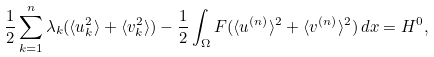<formula> <loc_0><loc_0><loc_500><loc_500>\frac { 1 } { 2 } \sum _ { k = 1 } ^ { n } \lambda _ { k } ( \langle u _ { k } ^ { 2 } \rangle + \langle v _ { k } ^ { 2 } \rangle ) - \frac { 1 } { 2 } \int _ { \Omega } F ( \langle u ^ { ( n ) } \rangle ^ { 2 } + \langle v ^ { ( n ) } \rangle ^ { 2 } ) \, d x = H ^ { 0 } ,</formula> 